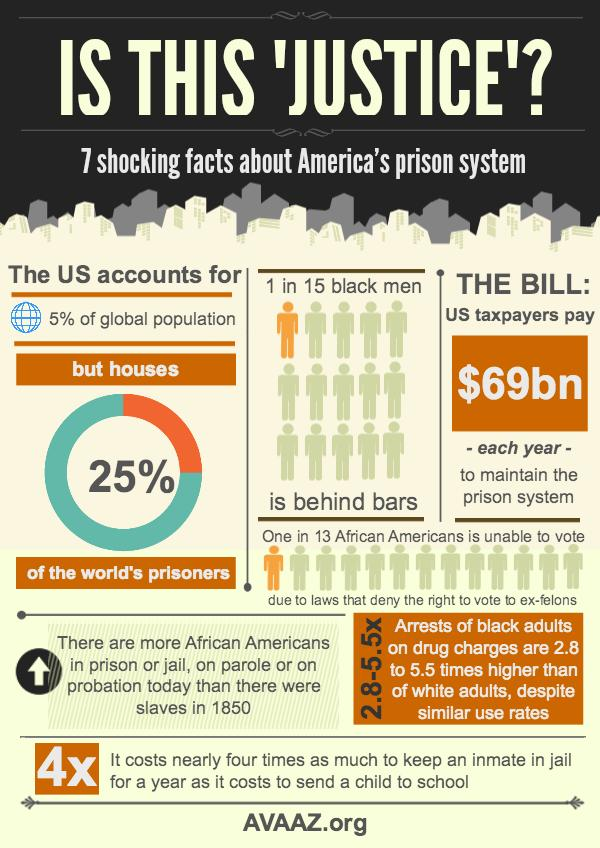Draw attention to some important aspects in this diagram. More than three-quarters of the world's prisoners are not American, according to recent data. It is estimated that 95% of the global population are not Americans. In total, there are 15 individuals, and of those, 14 are not currently incarcerated. Specifically, there are 14 black men who are not currently behind bars. 